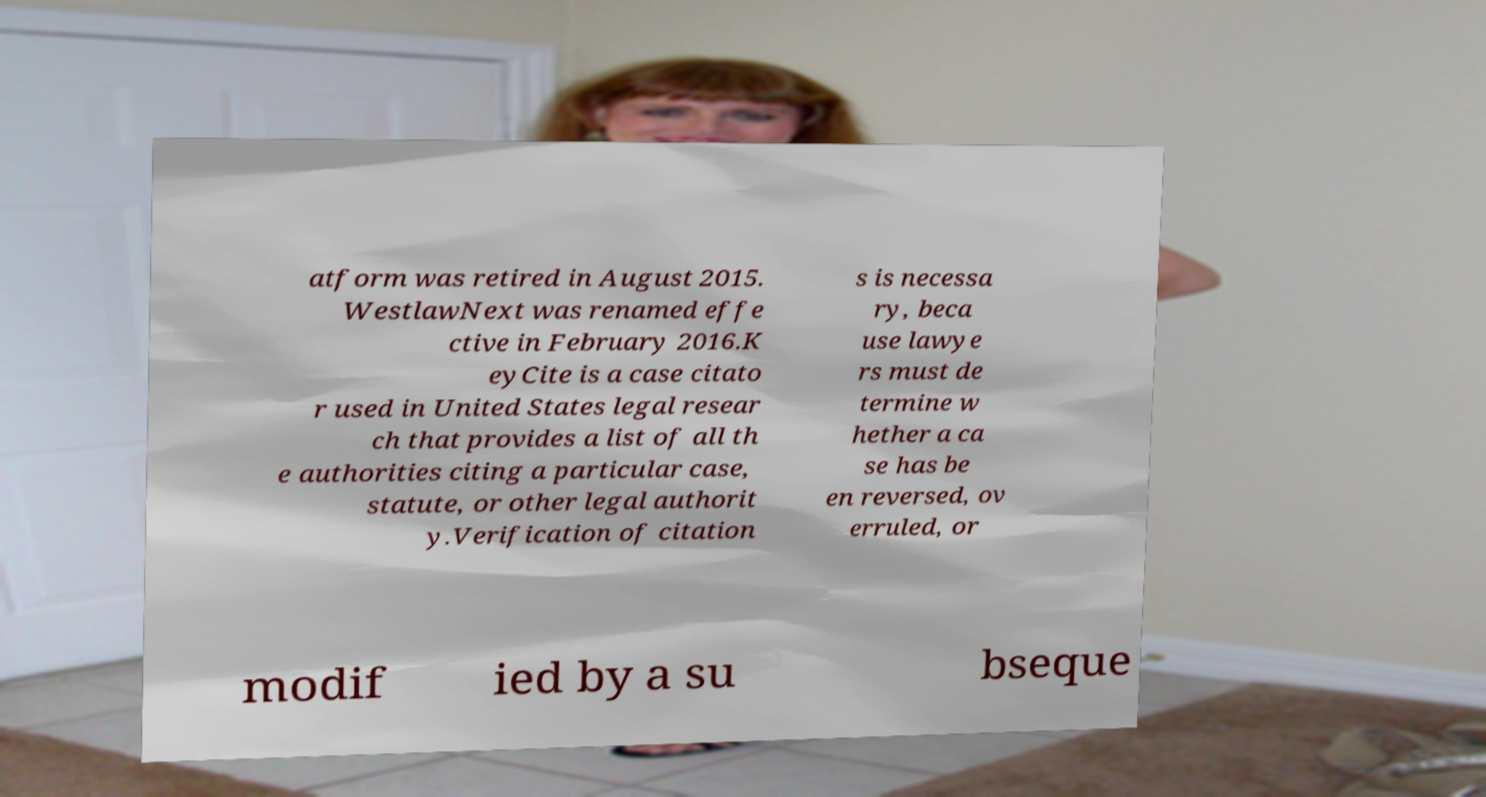For documentation purposes, I need the text within this image transcribed. Could you provide that? atform was retired in August 2015. WestlawNext was renamed effe ctive in February 2016.K eyCite is a case citato r used in United States legal resear ch that provides a list of all th e authorities citing a particular case, statute, or other legal authorit y.Verification of citation s is necessa ry, beca use lawye rs must de termine w hether a ca se has be en reversed, ov erruled, or modif ied by a su bseque 